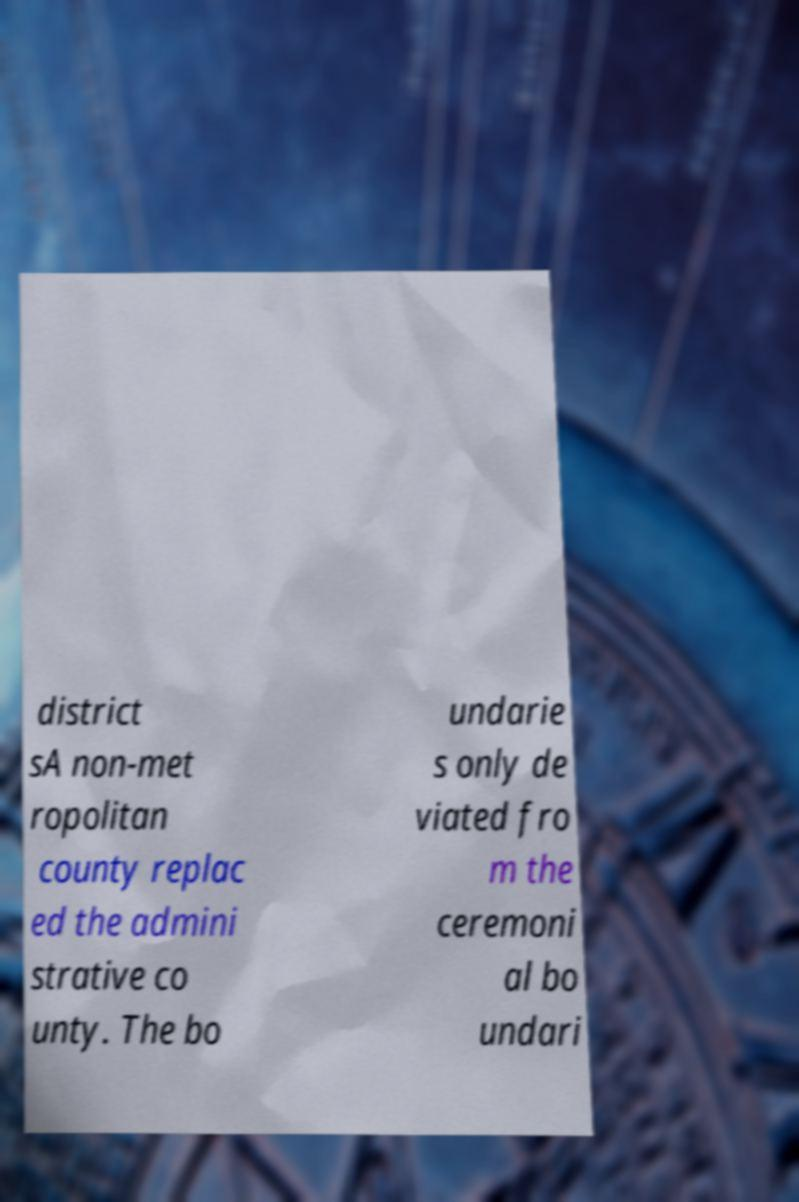For documentation purposes, I need the text within this image transcribed. Could you provide that? district sA non-met ropolitan county replac ed the admini strative co unty. The bo undarie s only de viated fro m the ceremoni al bo undari 